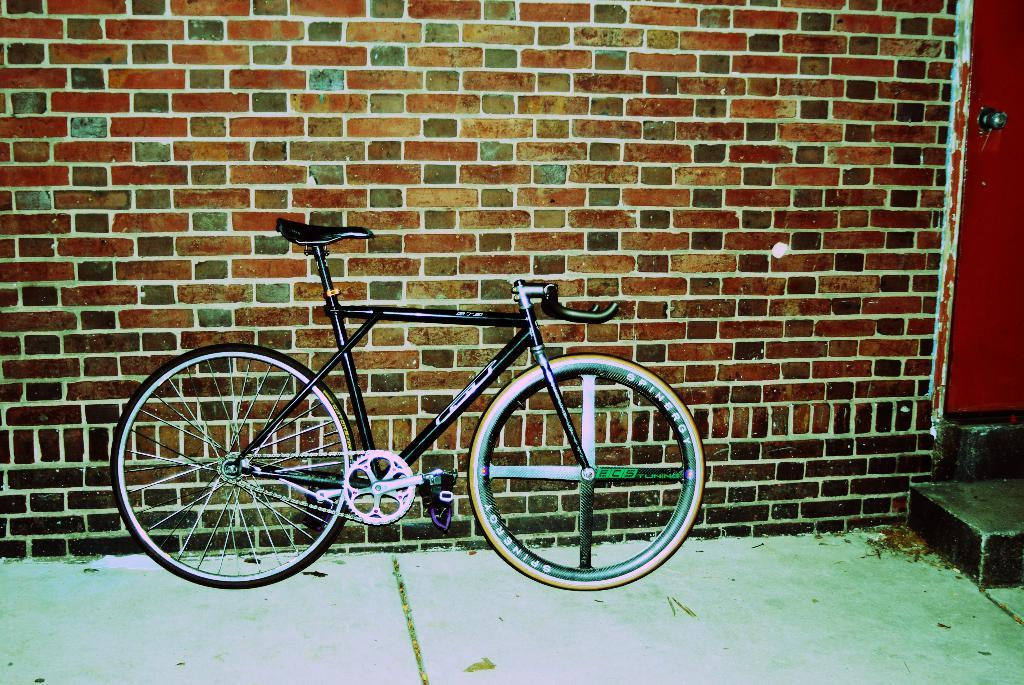What type of structure is visible in the image? There is a brick wall in the image. What is the color of the door in the image? There is a red color door in the image. What mode of transportation can be seen in the image? There is a bicycle in the image. What type of vegetable is being used as a pot in the image? There is no vegetable or pot present in the image. How does the bicycle roll in the image? The bicycle does not roll in the image; it is stationary. 